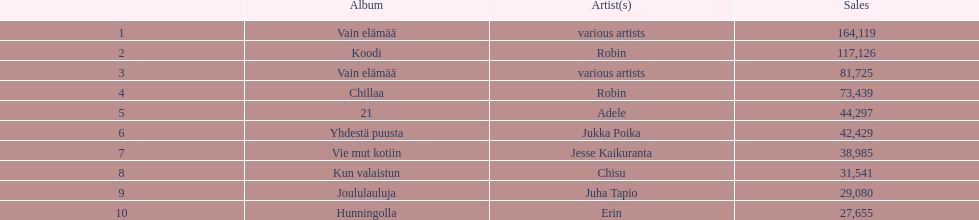Which album holds the record for most sales without having a specific artist credited? Vain elämää. 